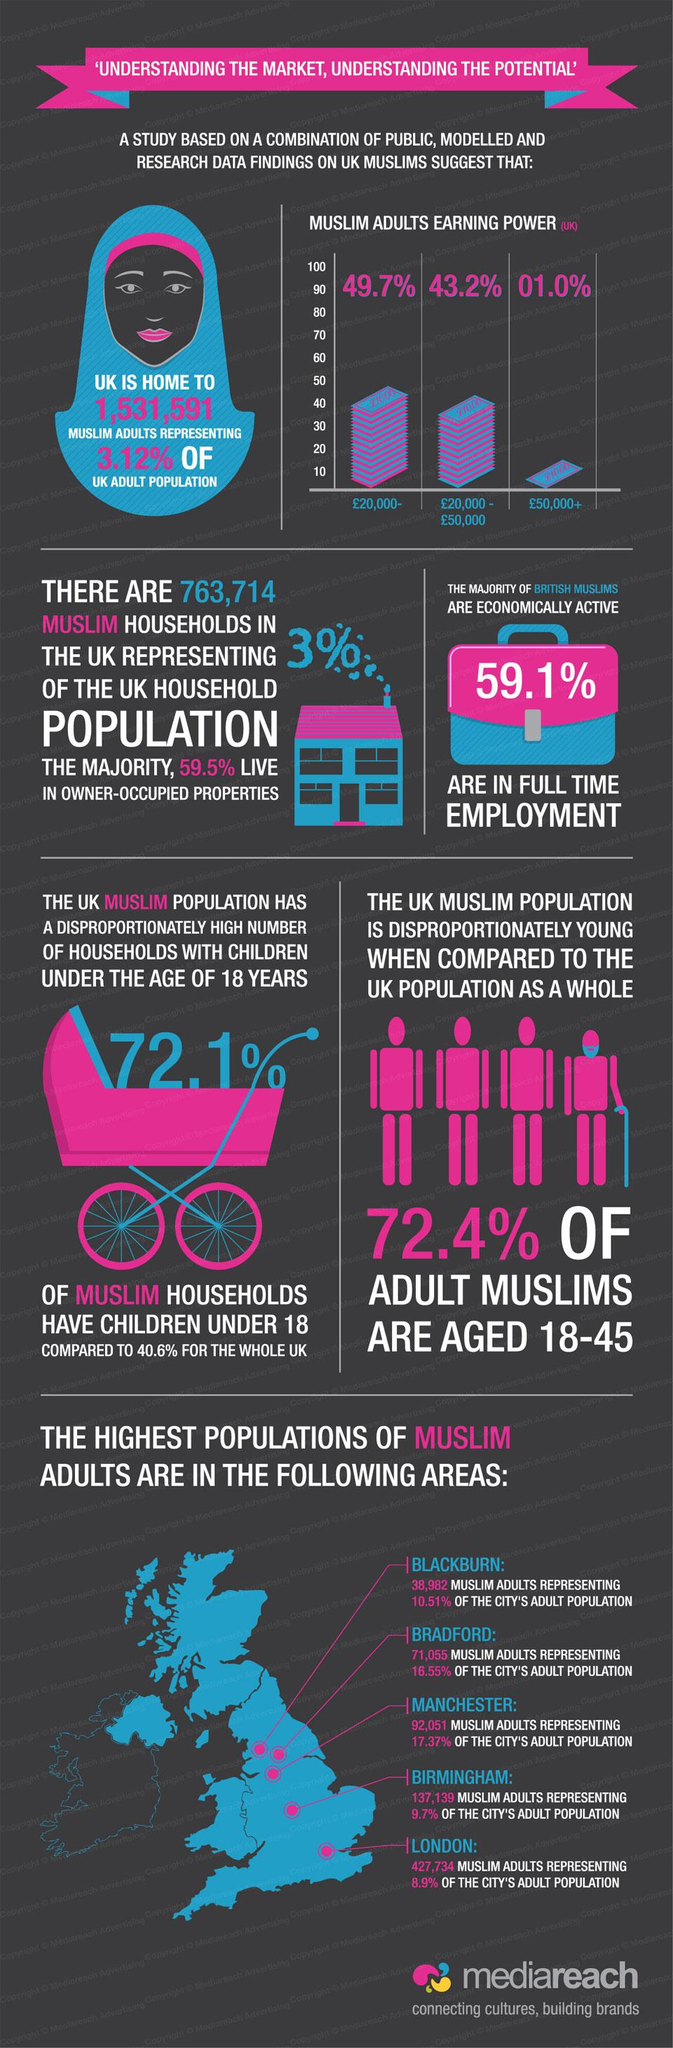Give some essential details in this illustration. According to recent statistics, only 3% of UK households are occupied by Muslims. According to the given information, it can be declared that approximately 72.1% of Muslim households have children under the age of 18. After London, which has the largest Muslim adult population, Birmingham is the area with the highest concentration of Muslim adults. According to statistics, only 3.12% of the adult population in the UK is represented by Muslims. The color of the walking stick is blue. 